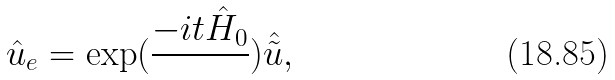<formula> <loc_0><loc_0><loc_500><loc_500>\hat { u } _ { e } = \exp ( \frac { - i t \hat { H } _ { 0 } } { } ) \hat { \tilde { u } } ,</formula> 